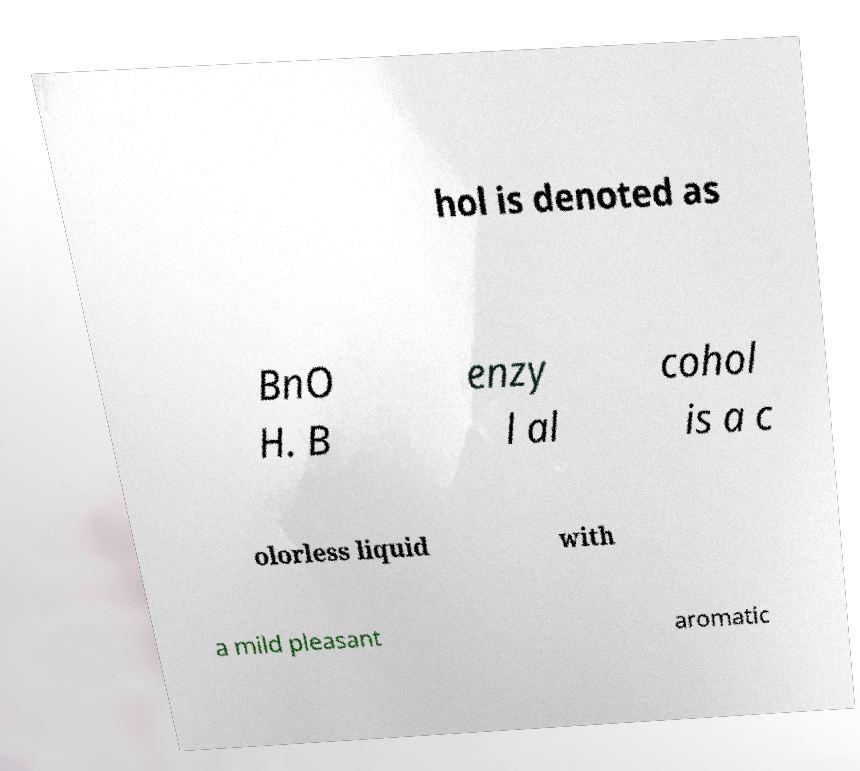Could you extract and type out the text from this image? hol is denoted as BnO H. B enzy l al cohol is a c olorless liquid with a mild pleasant aromatic 